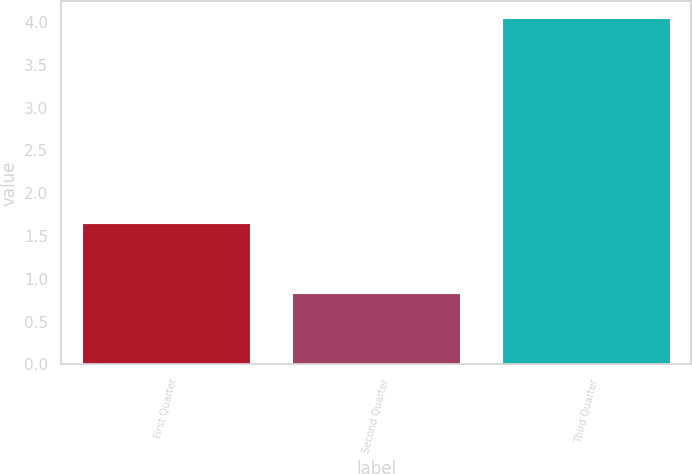<chart> <loc_0><loc_0><loc_500><loc_500><bar_chart><fcel>First Quarter<fcel>Second Quarter<fcel>Third Quarter<nl><fcel>1.65<fcel>0.83<fcel>4.04<nl></chart> 